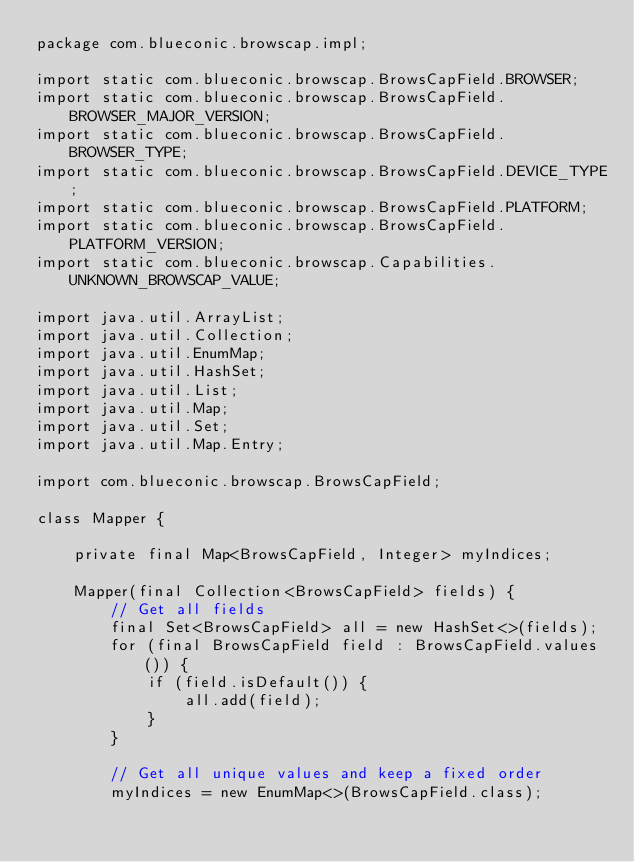<code> <loc_0><loc_0><loc_500><loc_500><_Java_>package com.blueconic.browscap.impl;

import static com.blueconic.browscap.BrowsCapField.BROWSER;
import static com.blueconic.browscap.BrowsCapField.BROWSER_MAJOR_VERSION;
import static com.blueconic.browscap.BrowsCapField.BROWSER_TYPE;
import static com.blueconic.browscap.BrowsCapField.DEVICE_TYPE;
import static com.blueconic.browscap.BrowsCapField.PLATFORM;
import static com.blueconic.browscap.BrowsCapField.PLATFORM_VERSION;
import static com.blueconic.browscap.Capabilities.UNKNOWN_BROWSCAP_VALUE;

import java.util.ArrayList;
import java.util.Collection;
import java.util.EnumMap;
import java.util.HashSet;
import java.util.List;
import java.util.Map;
import java.util.Set;
import java.util.Map.Entry;

import com.blueconic.browscap.BrowsCapField;

class Mapper {

    private final Map<BrowsCapField, Integer> myIndices;

    Mapper(final Collection<BrowsCapField> fields) {
        // Get all fields
        final Set<BrowsCapField> all = new HashSet<>(fields);
        for (final BrowsCapField field : BrowsCapField.values()) {
            if (field.isDefault()) {
                all.add(field);
            }
        }

        // Get all unique values and keep a fixed order
        myIndices = new EnumMap<>(BrowsCapField.class);</code> 